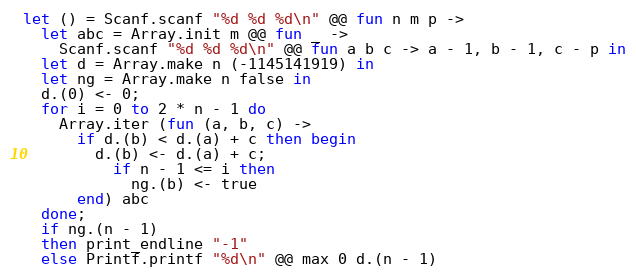Convert code to text. <code><loc_0><loc_0><loc_500><loc_500><_OCaml_>let () = Scanf.scanf "%d %d %d\n" @@ fun n m p ->
  let abc = Array.init m @@ fun _ ->
    Scanf.scanf "%d %d %d\n" @@ fun a b c -> a - 1, b - 1, c - p in
  let d = Array.make n (-1145141919) in
  let ng = Array.make n false in
  d.(0) <- 0;
  for i = 0 to 2 * n - 1 do
    Array.iter (fun (a, b, c) ->
      if d.(b) < d.(a) + c then begin
        d.(b) <- d.(a) + c;
          if n - 1 <= i then
            ng.(b) <- true
      end) abc
  done;
  if ng.(n - 1)
  then print_endline "-1"
  else Printf.printf "%d\n" @@ max 0 d.(n - 1)
</code> 